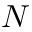<formula> <loc_0><loc_0><loc_500><loc_500>N</formula> 